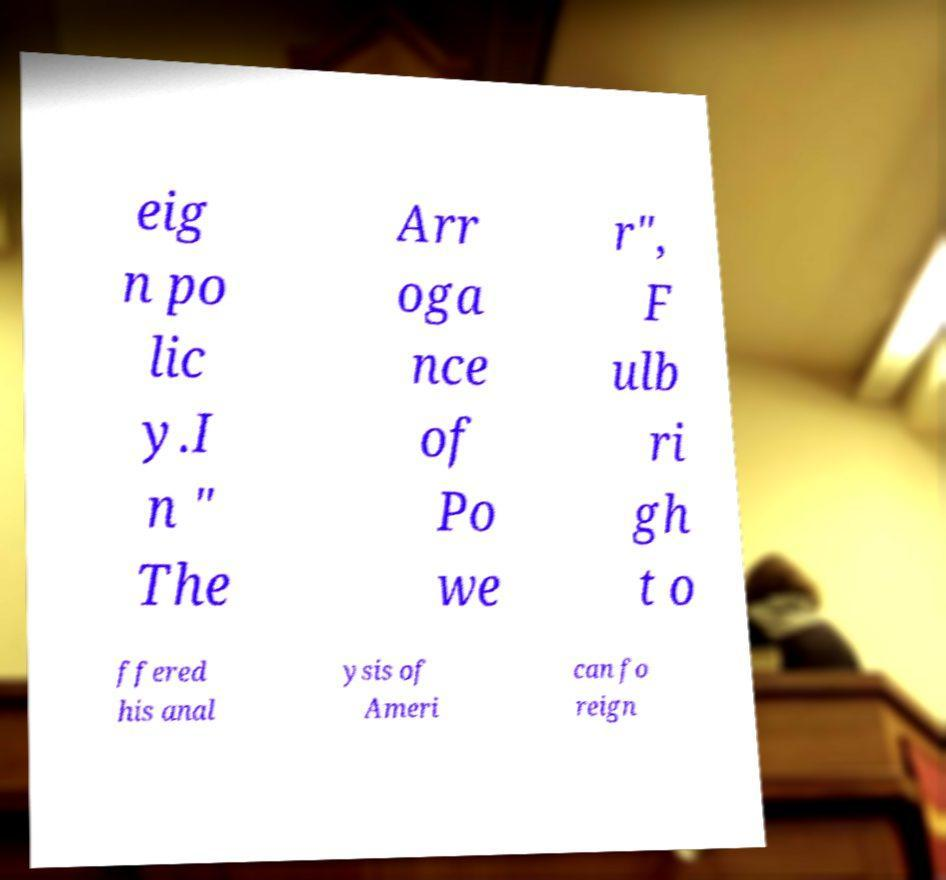What messages or text are displayed in this image? I need them in a readable, typed format. eig n po lic y.I n " The Arr oga nce of Po we r", F ulb ri gh t o ffered his anal ysis of Ameri can fo reign 